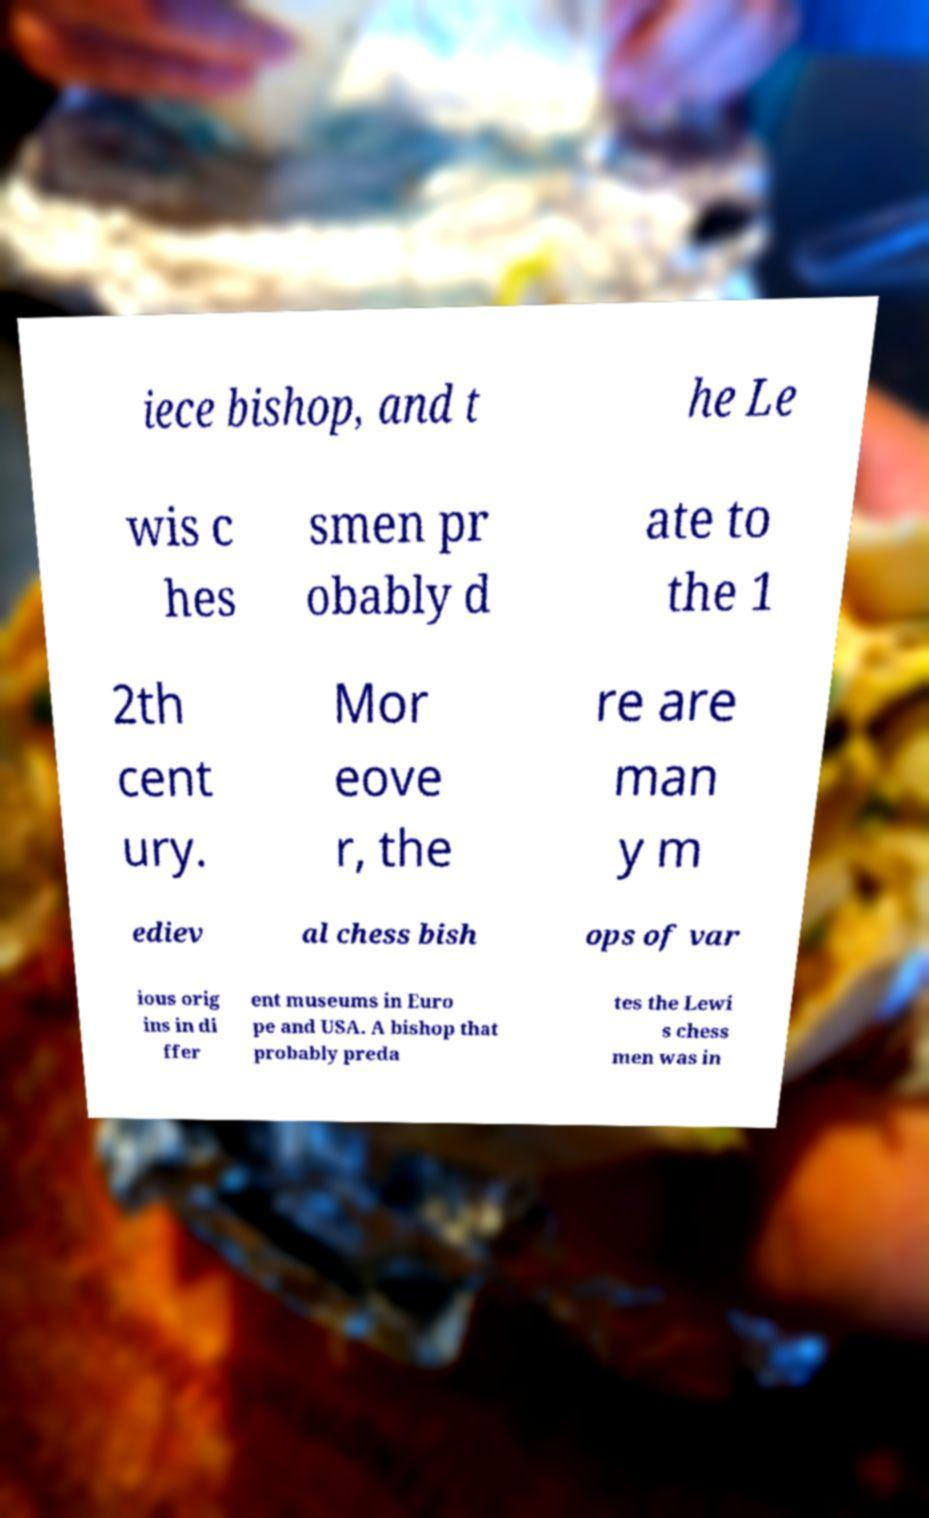What messages or text are displayed in this image? I need them in a readable, typed format. iece bishop, and t he Le wis c hes smen pr obably d ate to the 1 2th cent ury. Mor eove r, the re are man y m ediev al chess bish ops of var ious orig ins in di ffer ent museums in Euro pe and USA. A bishop that probably preda tes the Lewi s chess men was in 